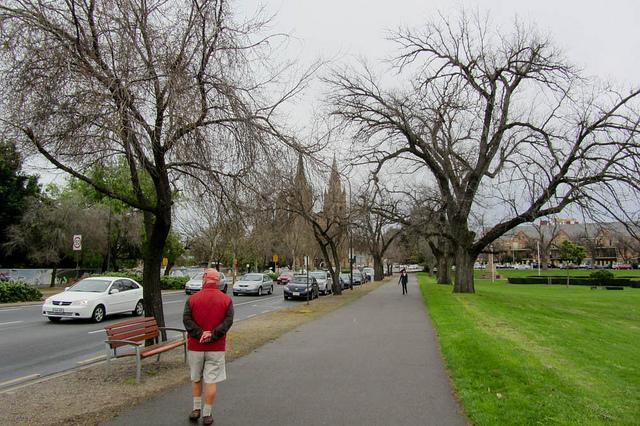What type trees are shown in the area nearest the red shirted walker? Please explain your reasoning. deciduous. The trees are bare and shed their leaves each year when the weather becomes cold. 